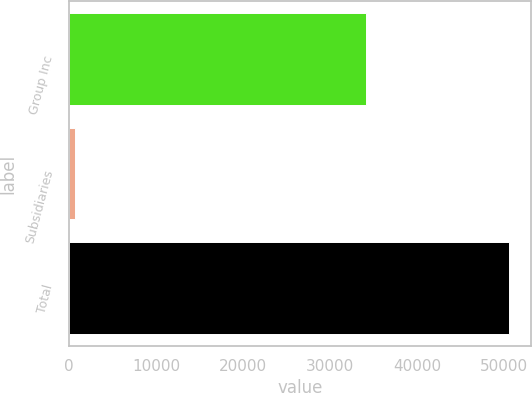<chart> <loc_0><loc_0><loc_500><loc_500><bar_chart><fcel>Group Inc<fcel>Subsidiaries<fcel>Total<nl><fcel>34146<fcel>711<fcel>50553<nl></chart> 